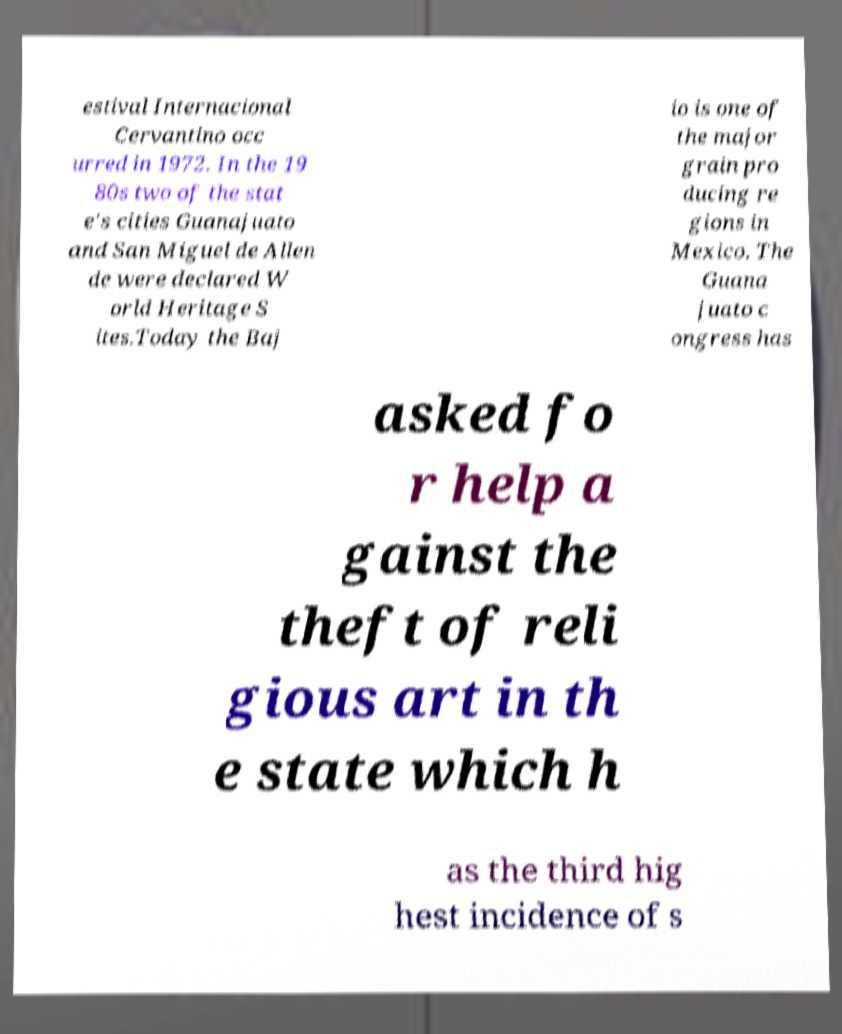What messages or text are displayed in this image? I need them in a readable, typed format. estival Internacional Cervantino occ urred in 1972. In the 19 80s two of the stat e's cities Guanajuato and San Miguel de Allen de were declared W orld Heritage S ites.Today the Baj io is one of the major grain pro ducing re gions in Mexico. The Guana juato c ongress has asked fo r help a gainst the theft of reli gious art in th e state which h as the third hig hest incidence of s 